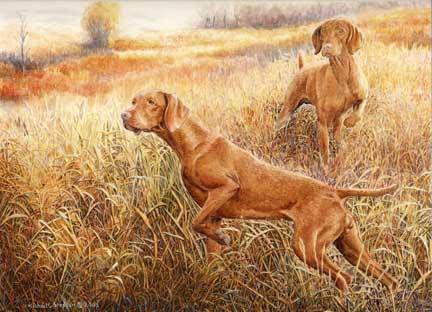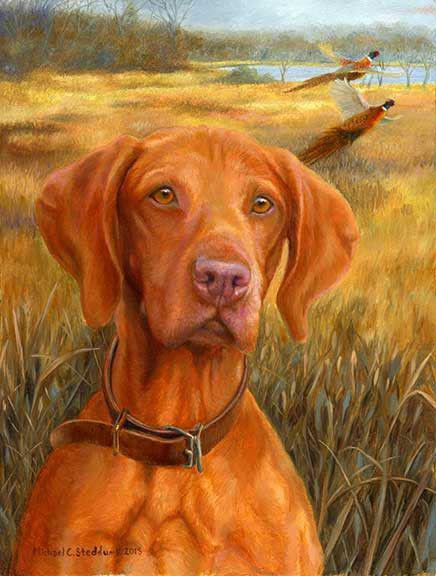The first image is the image on the left, the second image is the image on the right. For the images displayed, is the sentence "There are four dog ears visible." factually correct? Answer yes or no. No. The first image is the image on the left, the second image is the image on the right. For the images displayed, is the sentence "One image shows a red-orange hound gazing somewhat forward, and the other image includes a left-facing red-orange hound with the front paw closest to the camera raised." factually correct? Answer yes or no. Yes. 